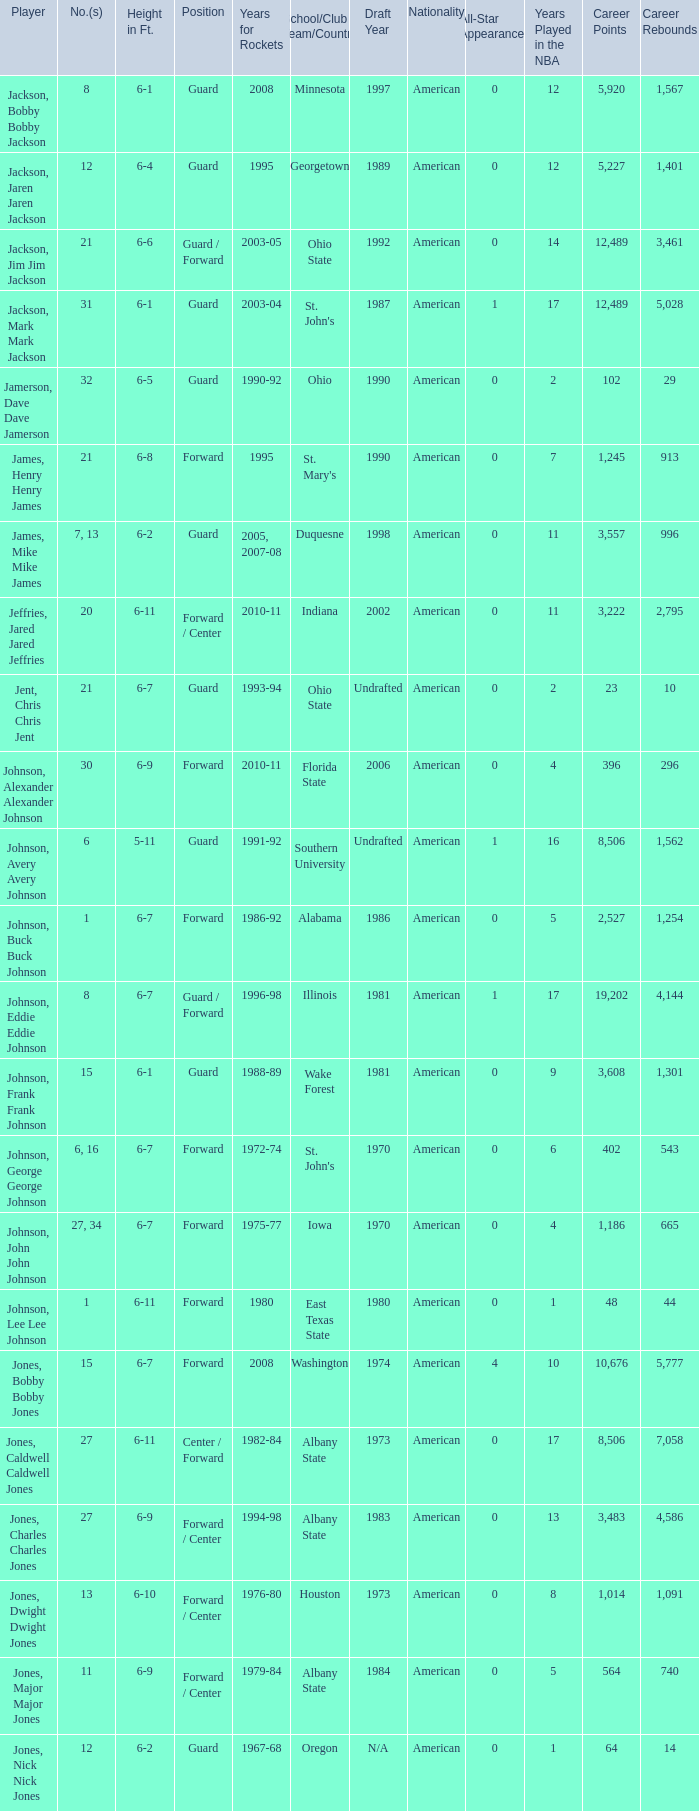What is the number of the player who went to Southern University? 6.0. Would you mind parsing the complete table? {'header': ['Player', 'No.(s)', 'Height in Ft.', 'Position', 'Years for Rockets', 'School/Club Team/Country', 'Draft Year', 'Nationality', 'All-Star Appearances', 'Years Played in the NBA', 'Career Points', 'Career Rebounds'], 'rows': [['Jackson, Bobby Bobby Jackson', '8', '6-1', 'Guard', '2008', 'Minnesota', '1997', 'American', '0', '12', '5,920', '1,567'], ['Jackson, Jaren Jaren Jackson', '12', '6-4', 'Guard', '1995', 'Georgetown', '1989', 'American', '0', '12', '5,227', '1,401'], ['Jackson, Jim Jim Jackson', '21', '6-6', 'Guard / Forward', '2003-05', 'Ohio State', '1992', 'American', '0', '14', '12,489', '3,461'], ['Jackson, Mark Mark Jackson', '31', '6-1', 'Guard', '2003-04', "St. John's", '1987', 'American', '1', '17', '12,489', '5,028'], ['Jamerson, Dave Dave Jamerson', '32', '6-5', 'Guard', '1990-92', 'Ohio', '1990', 'American', '0', '2', '102', '29'], ['James, Henry Henry James', '21', '6-8', 'Forward', '1995', "St. Mary's", '1990', 'American', '0', '7', '1,245', '913'], ['James, Mike Mike James', '7, 13', '6-2', 'Guard', '2005, 2007-08', 'Duquesne', '1998', 'American', '0', '11', '3,557', '996'], ['Jeffries, Jared Jared Jeffries', '20', '6-11', 'Forward / Center', '2010-11', 'Indiana', '2002', 'American', '0', '11', '3,222', '2,795'], ['Jent, Chris Chris Jent', '21', '6-7', 'Guard', '1993-94', 'Ohio State', 'Undrafted', 'American', '0', '2', '23', '10'], ['Johnson, Alexander Alexander Johnson', '30', '6-9', 'Forward', '2010-11', 'Florida State', '2006', 'American', '0', '4', '396', '296'], ['Johnson, Avery Avery Johnson', '6', '5-11', 'Guard', '1991-92', 'Southern University', 'Undrafted', 'American', '1', '16', '8,506', '1,562'], ['Johnson, Buck Buck Johnson', '1', '6-7', 'Forward', '1986-92', 'Alabama', '1986', 'American', '0', '5', '2,527', '1,254'], ['Johnson, Eddie Eddie Johnson', '8', '6-7', 'Guard / Forward', '1996-98', 'Illinois', '1981', 'American', '1', '17', '19,202', '4,144'], ['Johnson, Frank Frank Johnson', '15', '6-1', 'Guard', '1988-89', 'Wake Forest', '1981', 'American', '0', '9', '3,608', '1,301'], ['Johnson, George George Johnson', '6, 16', '6-7', 'Forward', '1972-74', "St. John's", '1970', 'American', '0', '6', '402', '543'], ['Johnson, John John Johnson', '27, 34', '6-7', 'Forward', '1975-77', 'Iowa', '1970', 'American', '0', '4', '1,186', '665'], ['Johnson, Lee Lee Johnson', '1', '6-11', 'Forward', '1980', 'East Texas State', '1980', 'American', '0', '1', '48', '44'], ['Jones, Bobby Bobby Jones', '15', '6-7', 'Forward', '2008', 'Washington', '1974', 'American', '4', '10', '10,676', '5,777'], ['Jones, Caldwell Caldwell Jones', '27', '6-11', 'Center / Forward', '1982-84', 'Albany State', '1973', 'American', '0', '17', '8,506', '7,058'], ['Jones, Charles Charles Jones', '27', '6-9', 'Forward / Center', '1994-98', 'Albany State', '1983', 'American', '0', '13', '3,483', '4,586'], ['Jones, Dwight Dwight Jones', '13', '6-10', 'Forward / Center', '1976-80', 'Houston', '1973', 'American', '0', '8', '1,014', '1,091'], ['Jones, Major Major Jones', '11', '6-9', 'Forward / Center', '1979-84', 'Albany State', '1984', 'American', '0', '5', '564', '740'], ['Jones, Nick Nick Jones', '12', '6-2', 'Guard', '1967-68', 'Oregon', 'N/A', 'American', '0', '1', '64', '14']]} 